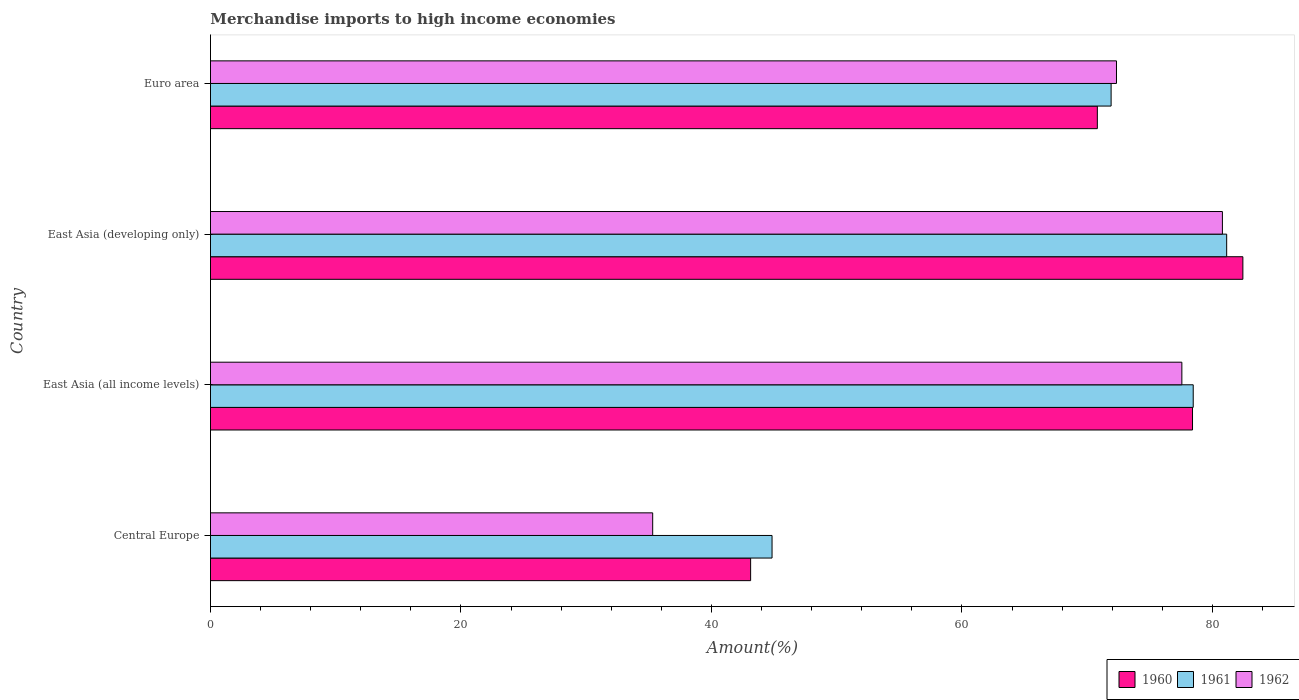How many different coloured bars are there?
Offer a very short reply. 3. Are the number of bars per tick equal to the number of legend labels?
Provide a succinct answer. Yes. Are the number of bars on each tick of the Y-axis equal?
Your answer should be very brief. Yes. How many bars are there on the 4th tick from the top?
Your answer should be compact. 3. What is the label of the 2nd group of bars from the top?
Give a very brief answer. East Asia (developing only). In how many cases, is the number of bars for a given country not equal to the number of legend labels?
Keep it short and to the point. 0. What is the percentage of amount earned from merchandise imports in 1960 in East Asia (developing only)?
Offer a terse response. 82.44. Across all countries, what is the maximum percentage of amount earned from merchandise imports in 1961?
Keep it short and to the point. 81.14. Across all countries, what is the minimum percentage of amount earned from merchandise imports in 1960?
Make the answer very short. 43.13. In which country was the percentage of amount earned from merchandise imports in 1962 maximum?
Offer a very short reply. East Asia (developing only). In which country was the percentage of amount earned from merchandise imports in 1962 minimum?
Offer a terse response. Central Europe. What is the total percentage of amount earned from merchandise imports in 1960 in the graph?
Make the answer very short. 274.79. What is the difference between the percentage of amount earned from merchandise imports in 1960 in East Asia (developing only) and that in Euro area?
Keep it short and to the point. 11.62. What is the difference between the percentage of amount earned from merchandise imports in 1961 in East Asia (all income levels) and the percentage of amount earned from merchandise imports in 1962 in Central Europe?
Your answer should be compact. 43.16. What is the average percentage of amount earned from merchandise imports in 1962 per country?
Your answer should be very brief. 66.5. What is the difference between the percentage of amount earned from merchandise imports in 1962 and percentage of amount earned from merchandise imports in 1960 in East Asia (developing only)?
Your response must be concise. -1.63. In how many countries, is the percentage of amount earned from merchandise imports in 1960 greater than 64 %?
Your answer should be very brief. 3. What is the ratio of the percentage of amount earned from merchandise imports in 1962 in Central Europe to that in East Asia (developing only)?
Make the answer very short. 0.44. Is the percentage of amount earned from merchandise imports in 1961 in Central Europe less than that in Euro area?
Ensure brevity in your answer.  Yes. What is the difference between the highest and the second highest percentage of amount earned from merchandise imports in 1960?
Your response must be concise. 4.02. What is the difference between the highest and the lowest percentage of amount earned from merchandise imports in 1960?
Keep it short and to the point. 39.31. What does the 2nd bar from the top in Central Europe represents?
Provide a succinct answer. 1961. How many bars are there?
Provide a succinct answer. 12. Are all the bars in the graph horizontal?
Your response must be concise. Yes. How many countries are there in the graph?
Your answer should be very brief. 4. What is the difference between two consecutive major ticks on the X-axis?
Your response must be concise. 20. Are the values on the major ticks of X-axis written in scientific E-notation?
Your answer should be very brief. No. Does the graph contain grids?
Ensure brevity in your answer.  No. What is the title of the graph?
Offer a terse response. Merchandise imports to high income economies. Does "1987" appear as one of the legend labels in the graph?
Your answer should be compact. No. What is the label or title of the X-axis?
Make the answer very short. Amount(%). What is the Amount(%) of 1960 in Central Europe?
Provide a succinct answer. 43.13. What is the Amount(%) in 1961 in Central Europe?
Keep it short and to the point. 44.84. What is the Amount(%) of 1962 in Central Europe?
Provide a short and direct response. 35.31. What is the Amount(%) of 1960 in East Asia (all income levels)?
Provide a short and direct response. 78.41. What is the Amount(%) of 1961 in East Asia (all income levels)?
Keep it short and to the point. 78.47. What is the Amount(%) of 1962 in East Asia (all income levels)?
Ensure brevity in your answer.  77.56. What is the Amount(%) in 1960 in East Asia (developing only)?
Keep it short and to the point. 82.44. What is the Amount(%) in 1961 in East Asia (developing only)?
Ensure brevity in your answer.  81.14. What is the Amount(%) in 1962 in East Asia (developing only)?
Your answer should be very brief. 80.8. What is the Amount(%) in 1960 in Euro area?
Your answer should be compact. 70.81. What is the Amount(%) of 1961 in Euro area?
Provide a short and direct response. 71.91. What is the Amount(%) in 1962 in Euro area?
Provide a short and direct response. 72.34. Across all countries, what is the maximum Amount(%) in 1960?
Your response must be concise. 82.44. Across all countries, what is the maximum Amount(%) in 1961?
Offer a terse response. 81.14. Across all countries, what is the maximum Amount(%) in 1962?
Your answer should be compact. 80.8. Across all countries, what is the minimum Amount(%) of 1960?
Offer a terse response. 43.13. Across all countries, what is the minimum Amount(%) of 1961?
Provide a short and direct response. 44.84. Across all countries, what is the minimum Amount(%) of 1962?
Your answer should be compact. 35.31. What is the total Amount(%) of 1960 in the graph?
Make the answer very short. 274.79. What is the total Amount(%) of 1961 in the graph?
Your answer should be very brief. 276.37. What is the total Amount(%) of 1962 in the graph?
Give a very brief answer. 266.02. What is the difference between the Amount(%) in 1960 in Central Europe and that in East Asia (all income levels)?
Keep it short and to the point. -35.28. What is the difference between the Amount(%) of 1961 in Central Europe and that in East Asia (all income levels)?
Your response must be concise. -33.63. What is the difference between the Amount(%) in 1962 in Central Europe and that in East Asia (all income levels)?
Provide a succinct answer. -42.25. What is the difference between the Amount(%) in 1960 in Central Europe and that in East Asia (developing only)?
Offer a terse response. -39.31. What is the difference between the Amount(%) of 1961 in Central Europe and that in East Asia (developing only)?
Your answer should be compact. -36.3. What is the difference between the Amount(%) in 1962 in Central Europe and that in East Asia (developing only)?
Your answer should be very brief. -45.49. What is the difference between the Amount(%) in 1960 in Central Europe and that in Euro area?
Your answer should be very brief. -27.69. What is the difference between the Amount(%) in 1961 in Central Europe and that in Euro area?
Offer a terse response. -27.07. What is the difference between the Amount(%) in 1962 in Central Europe and that in Euro area?
Offer a very short reply. -37.03. What is the difference between the Amount(%) in 1960 in East Asia (all income levels) and that in East Asia (developing only)?
Give a very brief answer. -4.02. What is the difference between the Amount(%) of 1961 in East Asia (all income levels) and that in East Asia (developing only)?
Your answer should be very brief. -2.67. What is the difference between the Amount(%) of 1962 in East Asia (all income levels) and that in East Asia (developing only)?
Provide a short and direct response. -3.24. What is the difference between the Amount(%) of 1960 in East Asia (all income levels) and that in Euro area?
Your answer should be very brief. 7.6. What is the difference between the Amount(%) in 1961 in East Asia (all income levels) and that in Euro area?
Provide a short and direct response. 6.56. What is the difference between the Amount(%) of 1962 in East Asia (all income levels) and that in Euro area?
Your answer should be very brief. 5.22. What is the difference between the Amount(%) in 1960 in East Asia (developing only) and that in Euro area?
Give a very brief answer. 11.62. What is the difference between the Amount(%) of 1961 in East Asia (developing only) and that in Euro area?
Keep it short and to the point. 9.23. What is the difference between the Amount(%) of 1962 in East Asia (developing only) and that in Euro area?
Your response must be concise. 8.46. What is the difference between the Amount(%) in 1960 in Central Europe and the Amount(%) in 1961 in East Asia (all income levels)?
Offer a very short reply. -35.34. What is the difference between the Amount(%) in 1960 in Central Europe and the Amount(%) in 1962 in East Asia (all income levels)?
Ensure brevity in your answer.  -34.43. What is the difference between the Amount(%) in 1961 in Central Europe and the Amount(%) in 1962 in East Asia (all income levels)?
Keep it short and to the point. -32.72. What is the difference between the Amount(%) of 1960 in Central Europe and the Amount(%) of 1961 in East Asia (developing only)?
Offer a terse response. -38.01. What is the difference between the Amount(%) of 1960 in Central Europe and the Amount(%) of 1962 in East Asia (developing only)?
Ensure brevity in your answer.  -37.67. What is the difference between the Amount(%) of 1961 in Central Europe and the Amount(%) of 1962 in East Asia (developing only)?
Your response must be concise. -35.96. What is the difference between the Amount(%) in 1960 in Central Europe and the Amount(%) in 1961 in Euro area?
Offer a very short reply. -28.78. What is the difference between the Amount(%) in 1960 in Central Europe and the Amount(%) in 1962 in Euro area?
Your response must be concise. -29.21. What is the difference between the Amount(%) in 1961 in Central Europe and the Amount(%) in 1962 in Euro area?
Keep it short and to the point. -27.5. What is the difference between the Amount(%) of 1960 in East Asia (all income levels) and the Amount(%) of 1961 in East Asia (developing only)?
Your answer should be compact. -2.73. What is the difference between the Amount(%) of 1960 in East Asia (all income levels) and the Amount(%) of 1962 in East Asia (developing only)?
Offer a terse response. -2.39. What is the difference between the Amount(%) in 1961 in East Asia (all income levels) and the Amount(%) in 1962 in East Asia (developing only)?
Keep it short and to the point. -2.33. What is the difference between the Amount(%) in 1960 in East Asia (all income levels) and the Amount(%) in 1961 in Euro area?
Provide a short and direct response. 6.5. What is the difference between the Amount(%) of 1960 in East Asia (all income levels) and the Amount(%) of 1962 in Euro area?
Your answer should be very brief. 6.07. What is the difference between the Amount(%) of 1961 in East Asia (all income levels) and the Amount(%) of 1962 in Euro area?
Give a very brief answer. 6.13. What is the difference between the Amount(%) of 1960 in East Asia (developing only) and the Amount(%) of 1961 in Euro area?
Your response must be concise. 10.52. What is the difference between the Amount(%) of 1960 in East Asia (developing only) and the Amount(%) of 1962 in Euro area?
Make the answer very short. 10.09. What is the difference between the Amount(%) in 1961 in East Asia (developing only) and the Amount(%) in 1962 in Euro area?
Offer a terse response. 8.8. What is the average Amount(%) in 1960 per country?
Your answer should be very brief. 68.7. What is the average Amount(%) of 1961 per country?
Your answer should be very brief. 69.09. What is the average Amount(%) of 1962 per country?
Give a very brief answer. 66.5. What is the difference between the Amount(%) in 1960 and Amount(%) in 1961 in Central Europe?
Offer a terse response. -1.71. What is the difference between the Amount(%) of 1960 and Amount(%) of 1962 in Central Europe?
Ensure brevity in your answer.  7.82. What is the difference between the Amount(%) of 1961 and Amount(%) of 1962 in Central Europe?
Your answer should be compact. 9.53. What is the difference between the Amount(%) in 1960 and Amount(%) in 1961 in East Asia (all income levels)?
Provide a succinct answer. -0.06. What is the difference between the Amount(%) in 1960 and Amount(%) in 1962 in East Asia (all income levels)?
Your answer should be very brief. 0.85. What is the difference between the Amount(%) of 1961 and Amount(%) of 1962 in East Asia (all income levels)?
Ensure brevity in your answer.  0.91. What is the difference between the Amount(%) of 1960 and Amount(%) of 1961 in East Asia (developing only)?
Give a very brief answer. 1.29. What is the difference between the Amount(%) in 1960 and Amount(%) in 1962 in East Asia (developing only)?
Give a very brief answer. 1.63. What is the difference between the Amount(%) in 1961 and Amount(%) in 1962 in East Asia (developing only)?
Give a very brief answer. 0.34. What is the difference between the Amount(%) of 1960 and Amount(%) of 1961 in Euro area?
Provide a succinct answer. -1.1. What is the difference between the Amount(%) of 1960 and Amount(%) of 1962 in Euro area?
Provide a short and direct response. -1.53. What is the difference between the Amount(%) in 1961 and Amount(%) in 1962 in Euro area?
Your response must be concise. -0.43. What is the ratio of the Amount(%) in 1960 in Central Europe to that in East Asia (all income levels)?
Your response must be concise. 0.55. What is the ratio of the Amount(%) of 1961 in Central Europe to that in East Asia (all income levels)?
Give a very brief answer. 0.57. What is the ratio of the Amount(%) in 1962 in Central Europe to that in East Asia (all income levels)?
Offer a very short reply. 0.46. What is the ratio of the Amount(%) in 1960 in Central Europe to that in East Asia (developing only)?
Make the answer very short. 0.52. What is the ratio of the Amount(%) of 1961 in Central Europe to that in East Asia (developing only)?
Offer a terse response. 0.55. What is the ratio of the Amount(%) in 1962 in Central Europe to that in East Asia (developing only)?
Provide a short and direct response. 0.44. What is the ratio of the Amount(%) in 1960 in Central Europe to that in Euro area?
Give a very brief answer. 0.61. What is the ratio of the Amount(%) in 1961 in Central Europe to that in Euro area?
Your response must be concise. 0.62. What is the ratio of the Amount(%) in 1962 in Central Europe to that in Euro area?
Offer a very short reply. 0.49. What is the ratio of the Amount(%) of 1960 in East Asia (all income levels) to that in East Asia (developing only)?
Your answer should be very brief. 0.95. What is the ratio of the Amount(%) of 1961 in East Asia (all income levels) to that in East Asia (developing only)?
Keep it short and to the point. 0.97. What is the ratio of the Amount(%) in 1962 in East Asia (all income levels) to that in East Asia (developing only)?
Provide a succinct answer. 0.96. What is the ratio of the Amount(%) of 1960 in East Asia (all income levels) to that in Euro area?
Keep it short and to the point. 1.11. What is the ratio of the Amount(%) in 1961 in East Asia (all income levels) to that in Euro area?
Give a very brief answer. 1.09. What is the ratio of the Amount(%) in 1962 in East Asia (all income levels) to that in Euro area?
Keep it short and to the point. 1.07. What is the ratio of the Amount(%) of 1960 in East Asia (developing only) to that in Euro area?
Keep it short and to the point. 1.16. What is the ratio of the Amount(%) of 1961 in East Asia (developing only) to that in Euro area?
Offer a very short reply. 1.13. What is the ratio of the Amount(%) of 1962 in East Asia (developing only) to that in Euro area?
Keep it short and to the point. 1.12. What is the difference between the highest and the second highest Amount(%) in 1960?
Make the answer very short. 4.02. What is the difference between the highest and the second highest Amount(%) in 1961?
Your answer should be compact. 2.67. What is the difference between the highest and the second highest Amount(%) of 1962?
Ensure brevity in your answer.  3.24. What is the difference between the highest and the lowest Amount(%) of 1960?
Offer a terse response. 39.31. What is the difference between the highest and the lowest Amount(%) of 1961?
Give a very brief answer. 36.3. What is the difference between the highest and the lowest Amount(%) of 1962?
Offer a very short reply. 45.49. 